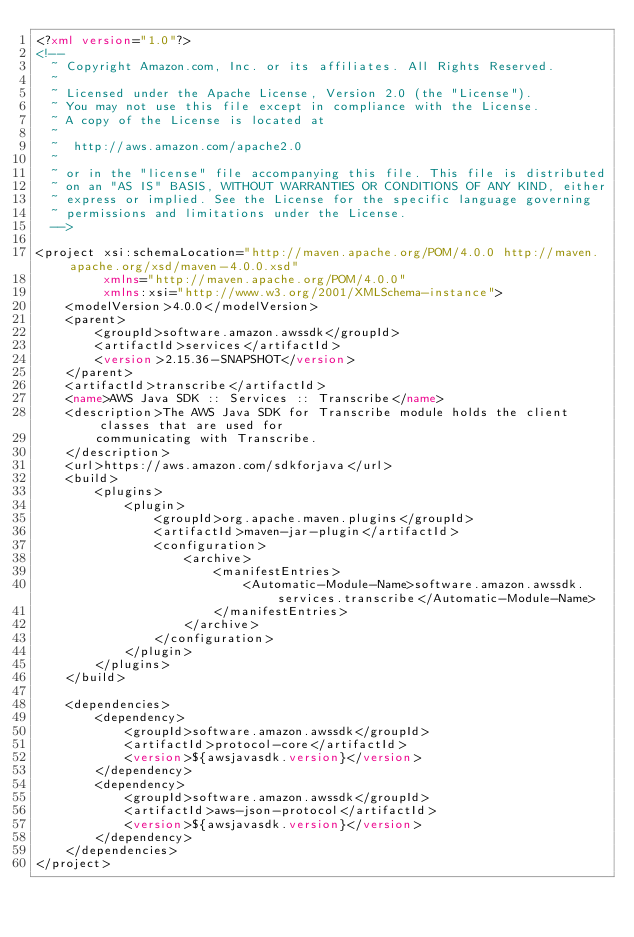<code> <loc_0><loc_0><loc_500><loc_500><_XML_><?xml version="1.0"?>
<!--
  ~ Copyright Amazon.com, Inc. or its affiliates. All Rights Reserved.
  ~
  ~ Licensed under the Apache License, Version 2.0 (the "License").
  ~ You may not use this file except in compliance with the License.
  ~ A copy of the License is located at
  ~
  ~  http://aws.amazon.com/apache2.0
  ~
  ~ or in the "license" file accompanying this file. This file is distributed
  ~ on an "AS IS" BASIS, WITHOUT WARRANTIES OR CONDITIONS OF ANY KIND, either
  ~ express or implied. See the License for the specific language governing
  ~ permissions and limitations under the License.
  -->

<project xsi:schemaLocation="http://maven.apache.org/POM/4.0.0 http://maven.apache.org/xsd/maven-4.0.0.xsd"
         xmlns="http://maven.apache.org/POM/4.0.0"
         xmlns:xsi="http://www.w3.org/2001/XMLSchema-instance">
    <modelVersion>4.0.0</modelVersion>
    <parent>
        <groupId>software.amazon.awssdk</groupId>
        <artifactId>services</artifactId>
        <version>2.15.36-SNAPSHOT</version>
    </parent>
    <artifactId>transcribe</artifactId>
    <name>AWS Java SDK :: Services :: Transcribe</name>
    <description>The AWS Java SDK for Transcribe module holds the client classes that are used for
        communicating with Transcribe.
    </description>
    <url>https://aws.amazon.com/sdkforjava</url>
    <build>
        <plugins>
            <plugin>
                <groupId>org.apache.maven.plugins</groupId>
                <artifactId>maven-jar-plugin</artifactId>
                <configuration>
                    <archive>
                        <manifestEntries>
                            <Automatic-Module-Name>software.amazon.awssdk.services.transcribe</Automatic-Module-Name>
                        </manifestEntries>
                    </archive>
                </configuration>
            </plugin>
        </plugins>
    </build>

    <dependencies>
        <dependency>
            <groupId>software.amazon.awssdk</groupId>
            <artifactId>protocol-core</artifactId>
            <version>${awsjavasdk.version}</version>
        </dependency>
        <dependency>
            <groupId>software.amazon.awssdk</groupId>
            <artifactId>aws-json-protocol</artifactId>
            <version>${awsjavasdk.version}</version>
        </dependency>
    </dependencies>
</project>
</code> 